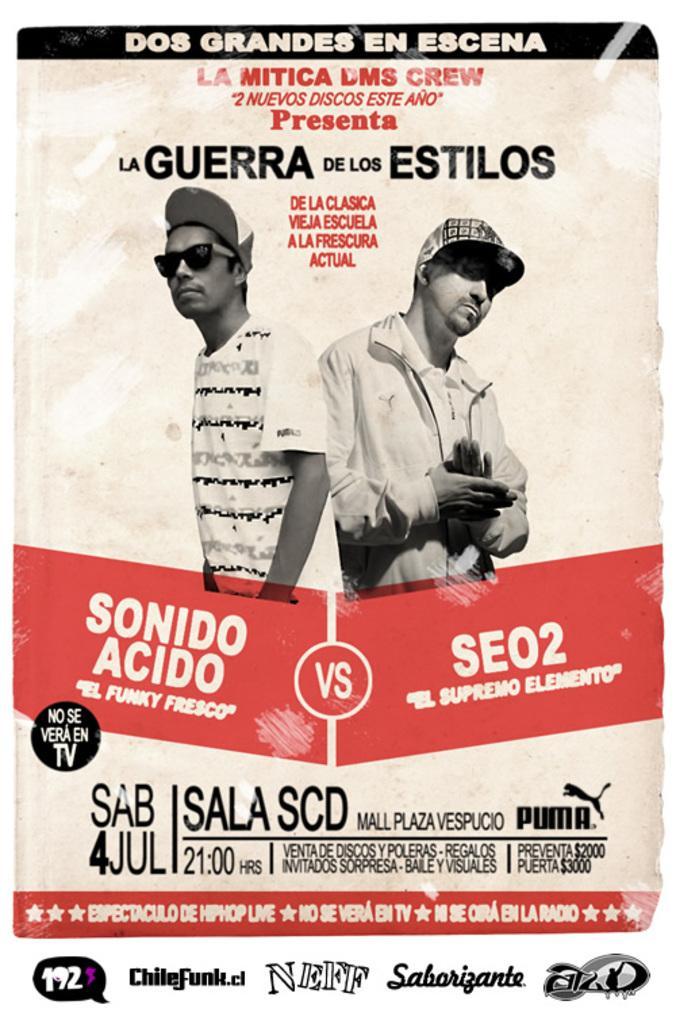In one or two sentences, can you explain what this image depicts? This image looks like a poster. There are two persons in the middle. This is an edited image. There is something written on this image. 